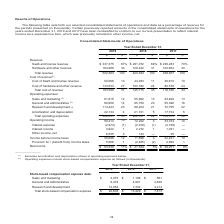According to Alarmcom Holdings's financial document, What was the amount of research and development in 2017? According to the financial document, 4,214 (in thousands). The relevant text states: "4,901 2,638 Research and development 12,054 7,332 4,214 Total stock-based compensation expense $ 20,603 $ 13,429 $ 7,413..." Also, What was the amount of sales and marketing in 2018? According to the financial document, 1,196 (in thousands). The relevant text states: "ation expense data: Sales and marketing $ 2,075 $ 1,196 $ 561 General and administrative 6,474 4,901 2,638 Research and development 12,054 7,332 4,214 Tota..." Also, What years does the table provide information for total stock-based compensation expense? The document contains multiple relevant values: 2019, 2018, 2017. From the document: "Year Ended December 31, 2019 2018 2017 $ % $ % $ % Revenue: SaaS and license revenue $ 337,375 67% $ 291,072 69% $ 236,283 70% Hardware an Year Ended ..." Also, can you calculate: What was the change in sales and marketing between 2017 and 2018? Based on the calculation: 1,196-561, the result is 635 (in thousands). This is based on the information: "pense data: Sales and marketing $ 2,075 $ 1,196 $ 561 General and administrative 6,474 4,901 2,638 Research and development 12,054 7,332 4,214 Total stoc ation expense data: Sales and marketing $ 2,07..." The key data points involved are: 1,196, 561. Also, How many years did sales and marketing exceed $1,000 thousand? Counting the relevant items in the document: 2019, 2018, I find 2 instances. The key data points involved are: 2018, 2019. Also, can you calculate: What was the percentage change in the amount of research and development between 2018 and 2019? To answer this question, I need to perform calculations using the financial data. The calculation is: (12,054-7,332)/7,332, which equals 64.4 (percentage). This is based on the information: "6,474 4,901 2,638 Research and development 12,054 7,332 4,214 Total stock-based compensation expense $ 20,603 $ 13,429 $ 7,413 rative 6,474 4,901 2,638 Research and development 12,054 7,332 4,214 Tota..." The key data points involved are: 12,054, 7,332. 